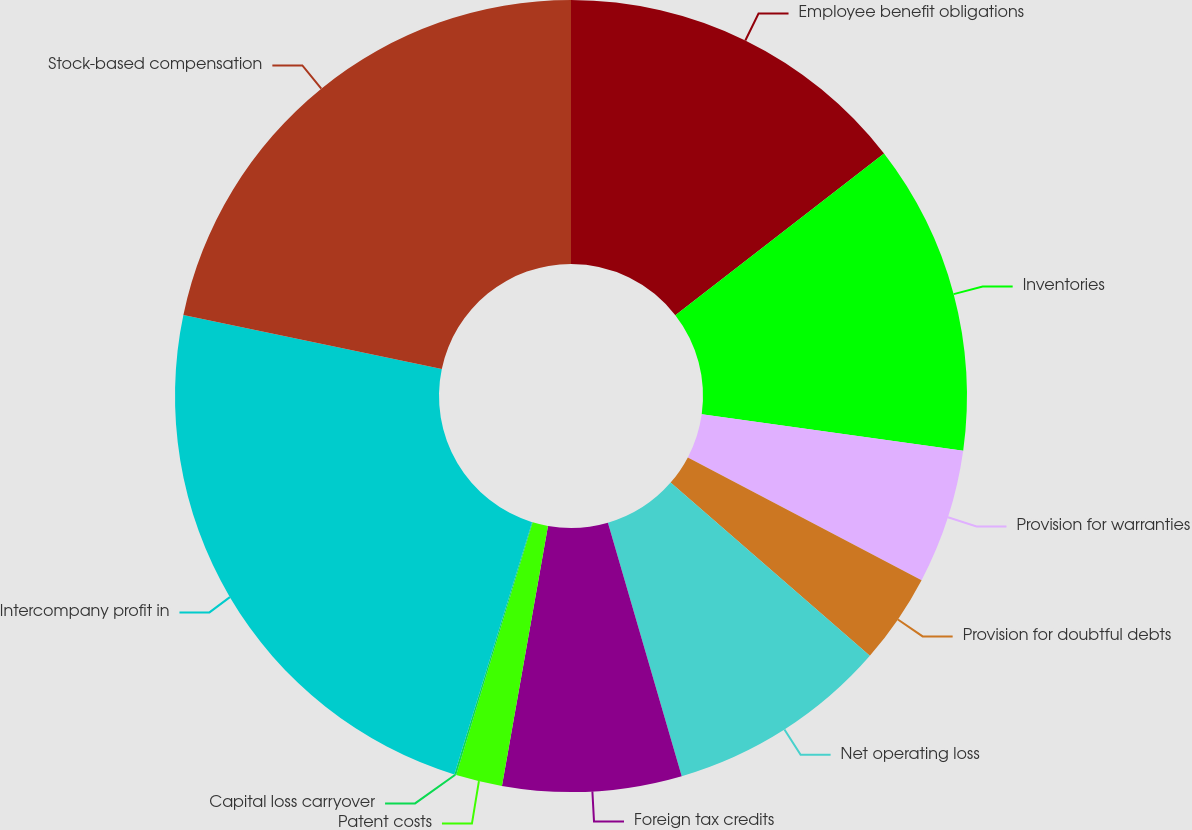Convert chart. <chart><loc_0><loc_0><loc_500><loc_500><pie_chart><fcel>Employee benefit obligations<fcel>Inventories<fcel>Provision for warranties<fcel>Provision for doubtful debts<fcel>Net operating loss<fcel>Foreign tax credits<fcel>Patent costs<fcel>Capital loss carryover<fcel>Intercompany profit in<fcel>Stock-based compensation<nl><fcel>14.51%<fcel>12.7%<fcel>5.49%<fcel>3.69%<fcel>9.1%<fcel>7.3%<fcel>1.89%<fcel>0.08%<fcel>23.52%<fcel>21.72%<nl></chart> 